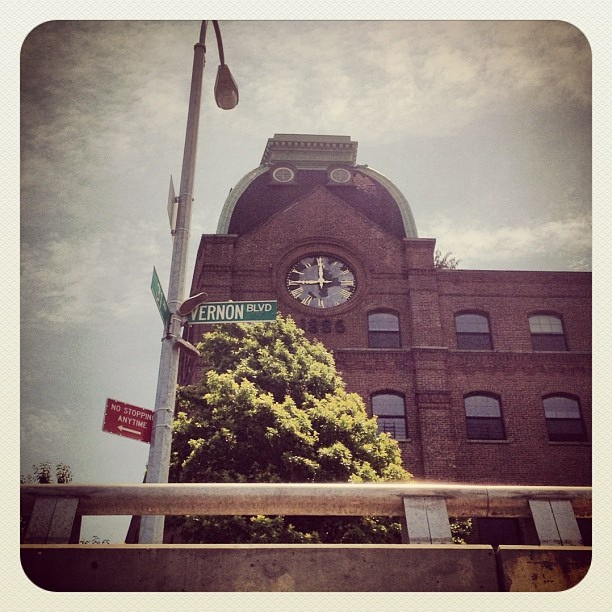Describe the objects in this image and their specific colors. I can see a clock in ivory, gray, and black tones in this image. 